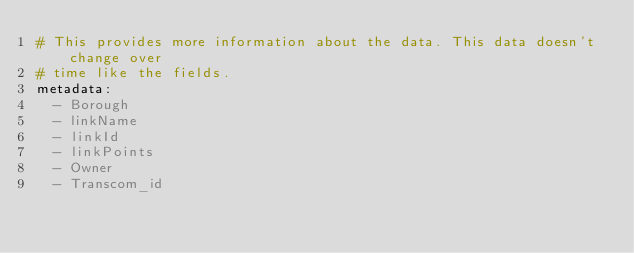<code> <loc_0><loc_0><loc_500><loc_500><_YAML_># This provides more information about the data. This data doesn't change over
# time like the fields.
metadata:
  - Borough
  - linkName
  - linkId
  - linkPoints
  - Owner
  - Transcom_id
</code> 